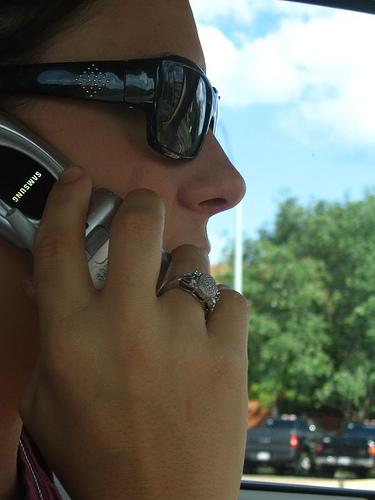What type of vehicle is in the background?
Be succinct. Truck. What is the probable sex of this human?
Keep it brief. Female. Is this woman married?
Be succinct. Yes. 